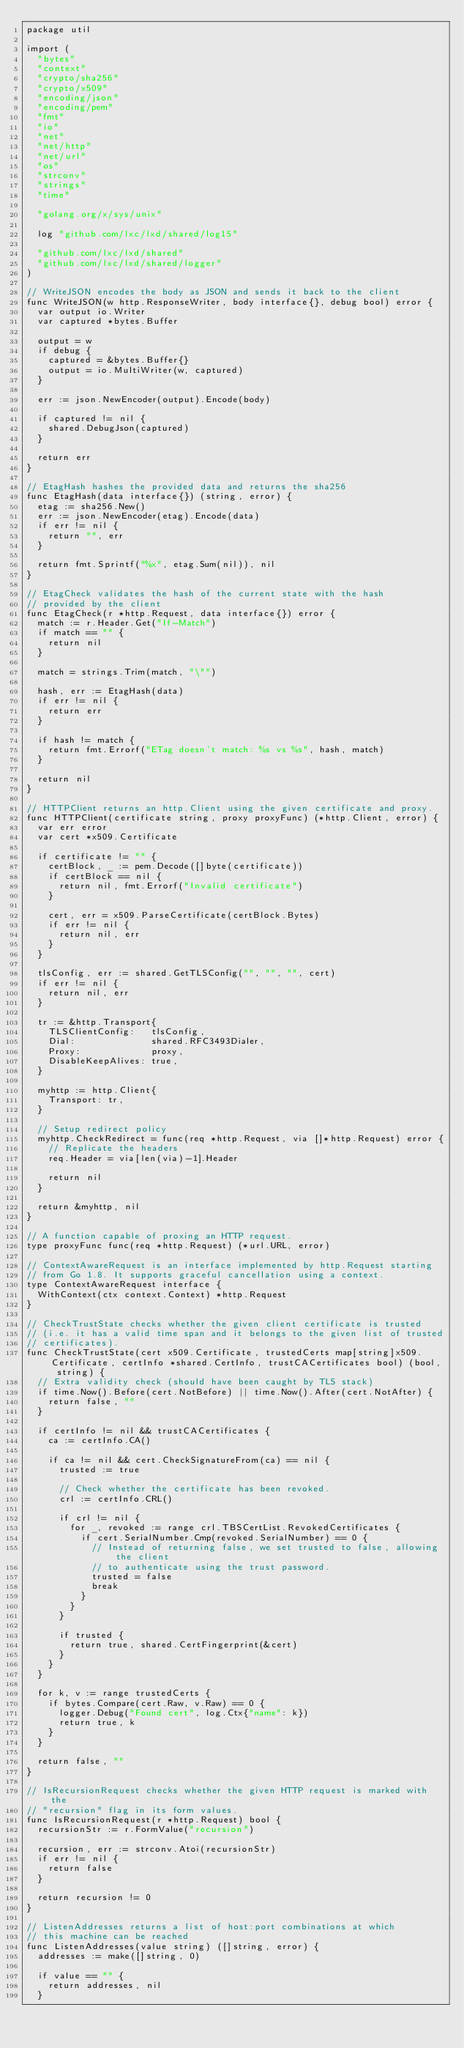Convert code to text. <code><loc_0><loc_0><loc_500><loc_500><_Go_>package util

import (
	"bytes"
	"context"
	"crypto/sha256"
	"crypto/x509"
	"encoding/json"
	"encoding/pem"
	"fmt"
	"io"
	"net"
	"net/http"
	"net/url"
	"os"
	"strconv"
	"strings"
	"time"

	"golang.org/x/sys/unix"

	log "github.com/lxc/lxd/shared/log15"

	"github.com/lxc/lxd/shared"
	"github.com/lxc/lxd/shared/logger"
)

// WriteJSON encodes the body as JSON and sends it back to the client
func WriteJSON(w http.ResponseWriter, body interface{}, debug bool) error {
	var output io.Writer
	var captured *bytes.Buffer

	output = w
	if debug {
		captured = &bytes.Buffer{}
		output = io.MultiWriter(w, captured)
	}

	err := json.NewEncoder(output).Encode(body)

	if captured != nil {
		shared.DebugJson(captured)
	}

	return err
}

// EtagHash hashes the provided data and returns the sha256
func EtagHash(data interface{}) (string, error) {
	etag := sha256.New()
	err := json.NewEncoder(etag).Encode(data)
	if err != nil {
		return "", err
	}

	return fmt.Sprintf("%x", etag.Sum(nil)), nil
}

// EtagCheck validates the hash of the current state with the hash
// provided by the client
func EtagCheck(r *http.Request, data interface{}) error {
	match := r.Header.Get("If-Match")
	if match == "" {
		return nil
	}

	match = strings.Trim(match, "\"")

	hash, err := EtagHash(data)
	if err != nil {
		return err
	}

	if hash != match {
		return fmt.Errorf("ETag doesn't match: %s vs %s", hash, match)
	}

	return nil
}

// HTTPClient returns an http.Client using the given certificate and proxy.
func HTTPClient(certificate string, proxy proxyFunc) (*http.Client, error) {
	var err error
	var cert *x509.Certificate

	if certificate != "" {
		certBlock, _ := pem.Decode([]byte(certificate))
		if certBlock == nil {
			return nil, fmt.Errorf("Invalid certificate")
		}

		cert, err = x509.ParseCertificate(certBlock.Bytes)
		if err != nil {
			return nil, err
		}
	}

	tlsConfig, err := shared.GetTLSConfig("", "", "", cert)
	if err != nil {
		return nil, err
	}

	tr := &http.Transport{
		TLSClientConfig:   tlsConfig,
		Dial:              shared.RFC3493Dialer,
		Proxy:             proxy,
		DisableKeepAlives: true,
	}

	myhttp := http.Client{
		Transport: tr,
	}

	// Setup redirect policy
	myhttp.CheckRedirect = func(req *http.Request, via []*http.Request) error {
		// Replicate the headers
		req.Header = via[len(via)-1].Header

		return nil
	}

	return &myhttp, nil
}

// A function capable of proxing an HTTP request.
type proxyFunc func(req *http.Request) (*url.URL, error)

// ContextAwareRequest is an interface implemented by http.Request starting
// from Go 1.8. It supports graceful cancellation using a context.
type ContextAwareRequest interface {
	WithContext(ctx context.Context) *http.Request
}

// CheckTrustState checks whether the given client certificate is trusted
// (i.e. it has a valid time span and it belongs to the given list of trusted
// certificates).
func CheckTrustState(cert x509.Certificate, trustedCerts map[string]x509.Certificate, certInfo *shared.CertInfo, trustCACertificates bool) (bool, string) {
	// Extra validity check (should have been caught by TLS stack)
	if time.Now().Before(cert.NotBefore) || time.Now().After(cert.NotAfter) {
		return false, ""
	}

	if certInfo != nil && trustCACertificates {
		ca := certInfo.CA()

		if ca != nil && cert.CheckSignatureFrom(ca) == nil {
			trusted := true

			// Check whether the certificate has been revoked.
			crl := certInfo.CRL()

			if crl != nil {
				for _, revoked := range crl.TBSCertList.RevokedCertificates {
					if cert.SerialNumber.Cmp(revoked.SerialNumber) == 0 {
						// Instead of returning false, we set trusted to false, allowing the client
						// to authenticate using the trust password.
						trusted = false
						break
					}
				}
			}

			if trusted {
				return true, shared.CertFingerprint(&cert)
			}
		}
	}

	for k, v := range trustedCerts {
		if bytes.Compare(cert.Raw, v.Raw) == 0 {
			logger.Debug("Found cert", log.Ctx{"name": k})
			return true, k
		}
	}

	return false, ""
}

// IsRecursionRequest checks whether the given HTTP request is marked with the
// "recursion" flag in its form values.
func IsRecursionRequest(r *http.Request) bool {
	recursionStr := r.FormValue("recursion")

	recursion, err := strconv.Atoi(recursionStr)
	if err != nil {
		return false
	}

	return recursion != 0
}

// ListenAddresses returns a list of host:port combinations at which
// this machine can be reached
func ListenAddresses(value string) ([]string, error) {
	addresses := make([]string, 0)

	if value == "" {
		return addresses, nil
	}
</code> 